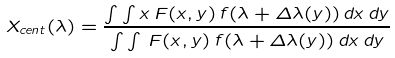Convert formula to latex. <formula><loc_0><loc_0><loc_500><loc_500>X _ { c e n t } ( \lambda ) = \frac { \int \int x \, F ( x , y ) \, f ( \lambda + \Delta \lambda ( y ) ) \, d x \, d y } { \int \int \, F ( x , y ) \, f ( \lambda + \Delta \lambda ( y ) ) \, d x \, d y }</formula> 